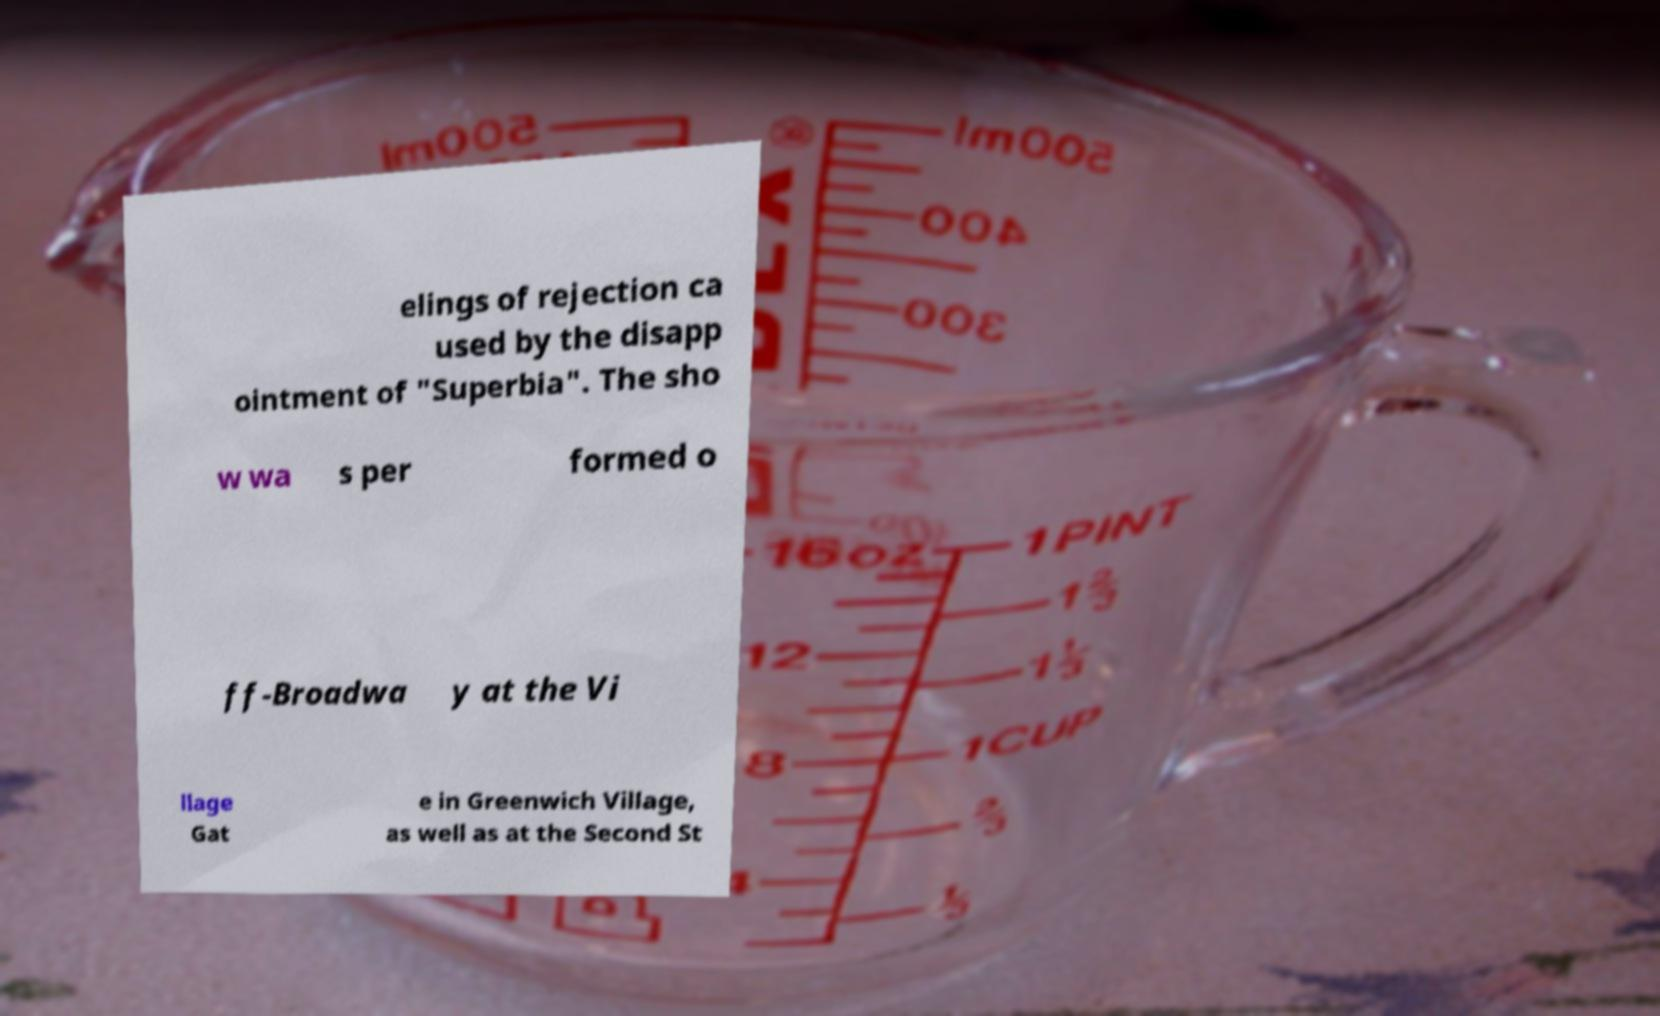For documentation purposes, I need the text within this image transcribed. Could you provide that? elings of rejection ca used by the disapp ointment of "Superbia". The sho w wa s per formed o ff-Broadwa y at the Vi llage Gat e in Greenwich Village, as well as at the Second St 